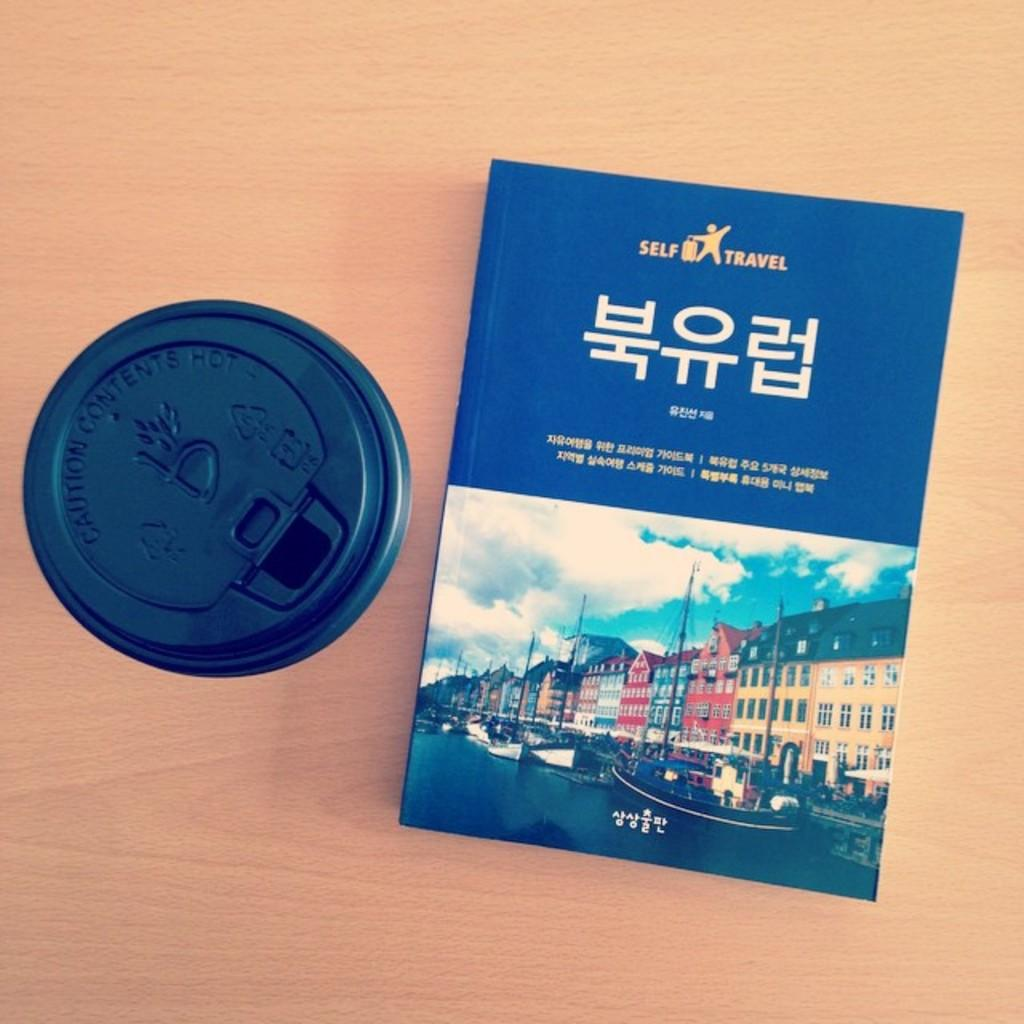<image>
Create a compact narrative representing the image presented. A HARD COVER ORIENTAL BOOK FOR THE SELF TRAVELER 